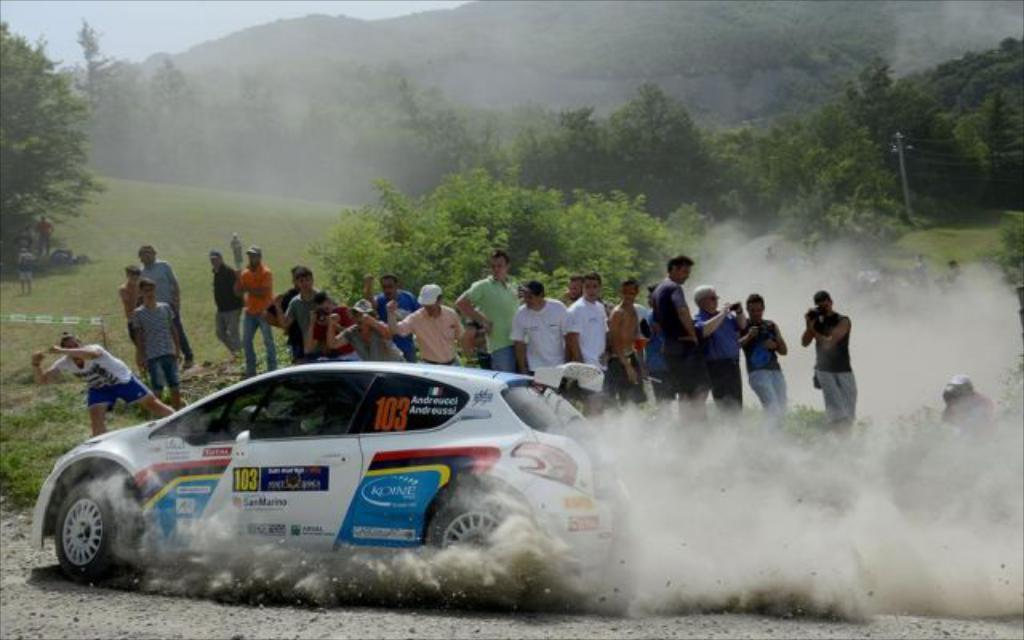Can you describe this image briefly? In this image we can see the mountains, so many trees, grass and so many people are standing and holding some objects. There is one antenna with wires and one pole. One racing car is on the road. At the top there is the sky. 